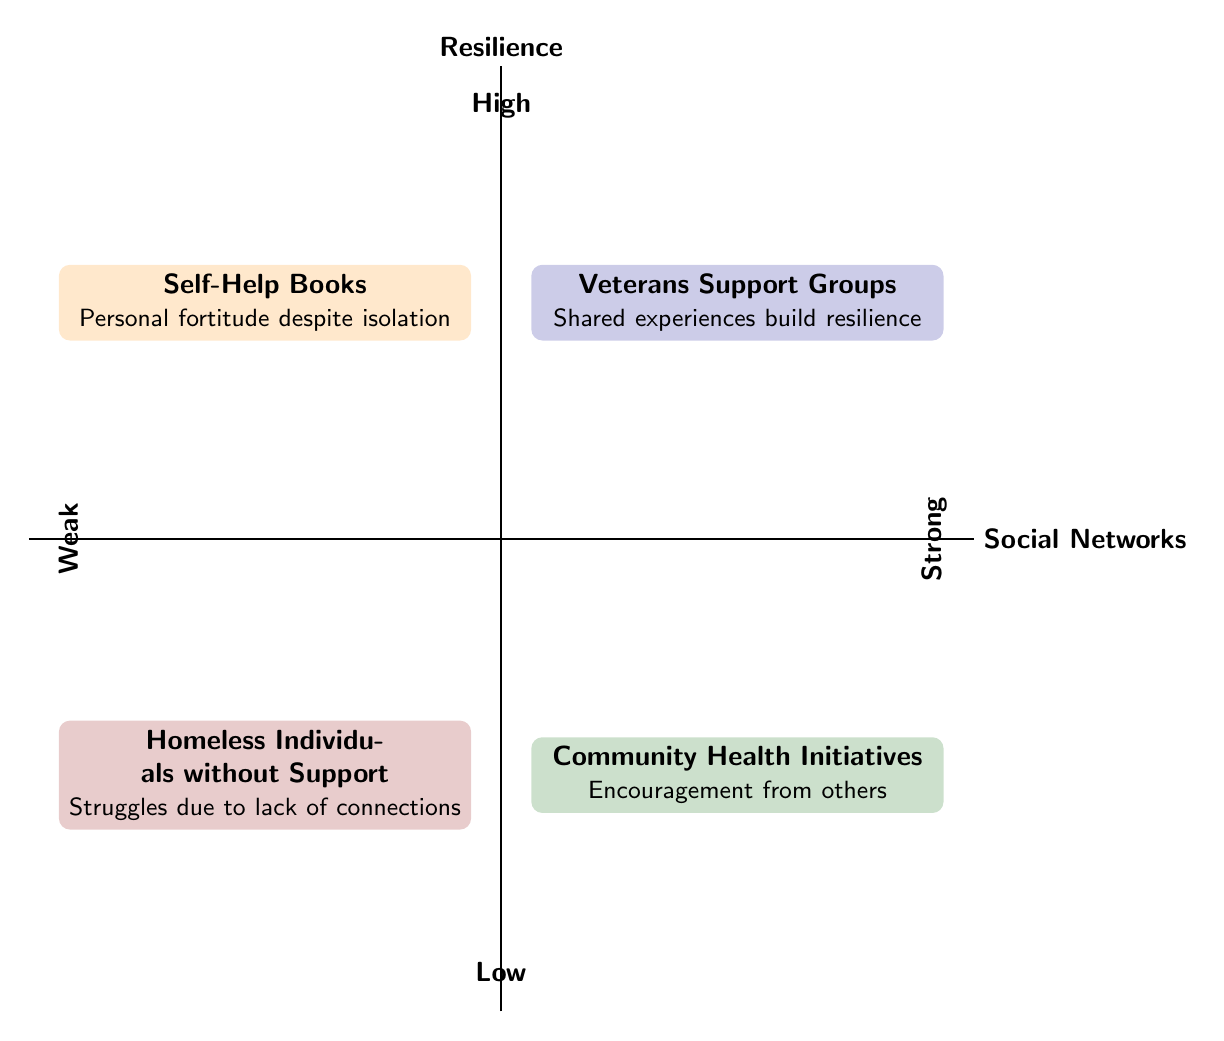What examples are presented in the "Strong Social Networks, High Resilience" quadrant? The quadrant labeled "Strong Social Networks, High Resilience" shows "Veterans Support Groups." This can be determined by locating the quadrant that is positioned in the top right of the chart.
Answer: Veterans Support Groups What is the defining element of the "Weak Social Networks, High Resilience" quadrant? The "Weak Social Networks, High Resilience" section identifies "Personal fortitude despite isolation" as its defining element. This is found by checking the information in the quadrant located in the top left of the chart.
Answer: Personal fortitude despite isolation How many quadrants are displayed in the chart? The diagram showcases a total of four quadrants, identified by the intersections of high/low resilience and strong/weak social networks. This is evident from the layout of the chart.
Answer: Four Which quadrant would most likely struggle due to lack of connections? The quadrant titled "Weak Social Networks, Low Resilience," which contains "Homeless Individuals without Support," is likely to struggle due to the lack of connections. This corresponds with the bottom left quadrant where both social networks and resilience are low.
Answer: Homeless Individuals without Support Which element emphasizes the importance of encouragement from others? The "Community Health Initiatives" in the "Strong Social Networks, Low Resilience" quadrant highlights the significance of encouragement from others. This is found in the bottom right section of the chart.
Answer: Encouragement from others What relationship can be inferred about "Self-Help Books" in terms of resilience? "Self-Help Books," located in the "Weak Social Networks, High Resilience" quadrant, indicates that personal resilience can still be cultivated even in isolation. Therefore, they suggest that resilience can exist independently of strong social networks.
Answer: Resilience can exist independently In which quadrant would you find the topic of shared experiences building resilience? The topic of shared experiences building resilience resides in the "Strong Social Networks, High Resilience" quadrant, specifically in the section that mentions "Veterans Support Groups." This is determined by locating the relevant quadrant in the top right corner.
Answer: Strong Social Networks, High Resilience Which quadrant represents the highest combination of resilience and social support? The quadrant that represents the highest combination of resilience and social support is "Strong Social Networks, High Resilience," characterized by "Veterans Support Groups." This is concluded by identifying the top right section of the diagram.
Answer: Strong Social Networks, High Resilience What does the position of "Homeless Individuals without Support" suggest about their resilience level? The position of "Homeless Individuals without Support" in the "Weak Social Networks, Low Resilience" quadrant suggests that they are likely to have low resilience. Hence, the lack of support correlates with their challenges, as indicated in the chart.
Answer: Low resilience 